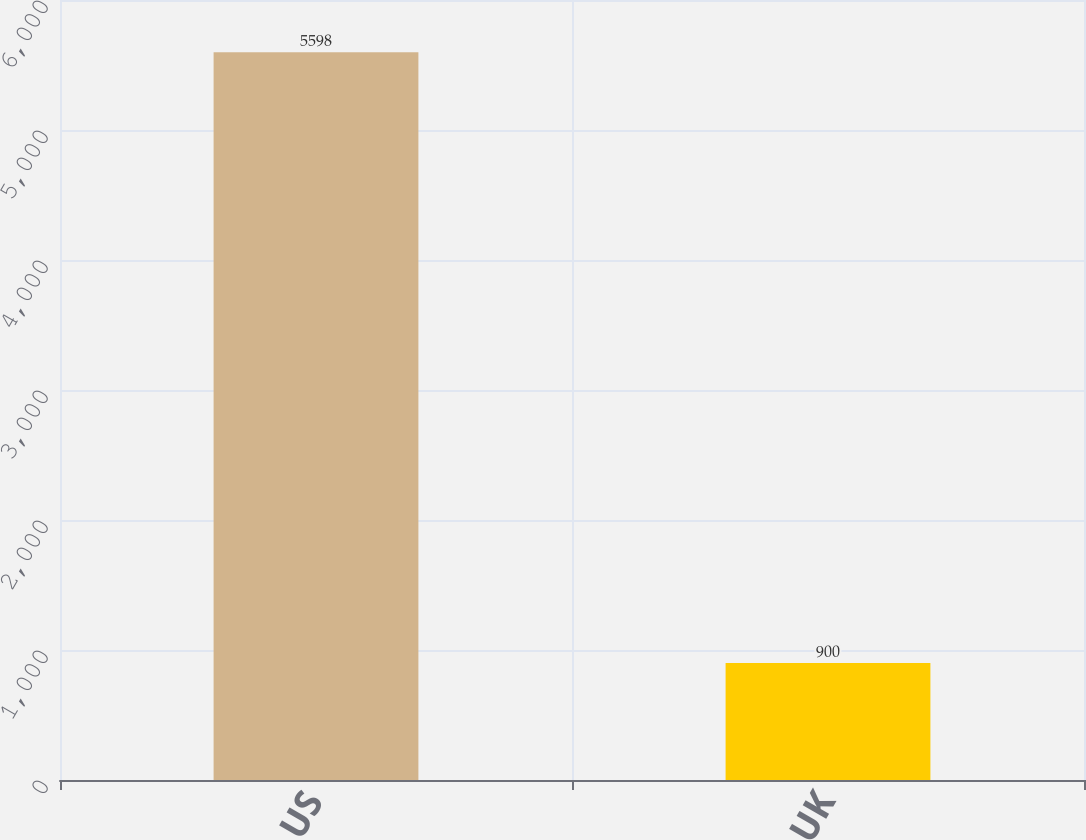Convert chart to OTSL. <chart><loc_0><loc_0><loc_500><loc_500><bar_chart><fcel>US<fcel>UK<nl><fcel>5598<fcel>900<nl></chart> 